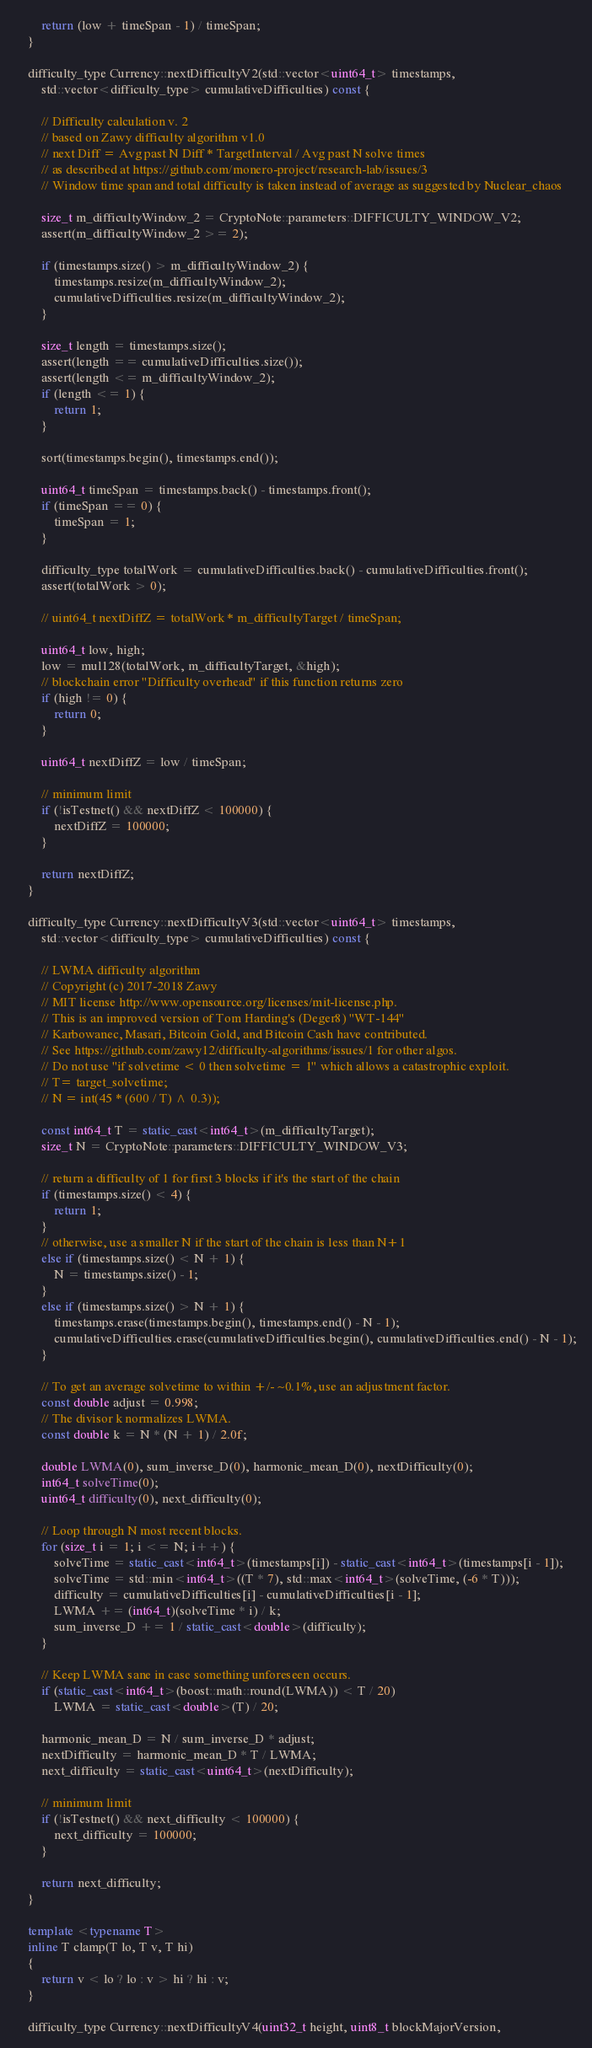<code> <loc_0><loc_0><loc_500><loc_500><_C++_>
		return (low + timeSpan - 1) / timeSpan;
	}

	difficulty_type Currency::nextDifficultyV2(std::vector<uint64_t> timestamps,
		std::vector<difficulty_type> cumulativeDifficulties) const {

		// Difficulty calculation v. 2
		// based on Zawy difficulty algorithm v1.0
		// next Diff = Avg past N Diff * TargetInterval / Avg past N solve times
		// as described at https://github.com/monero-project/research-lab/issues/3
		// Window time span and total difficulty is taken instead of average as suggested by Nuclear_chaos

		size_t m_difficultyWindow_2 = CryptoNote::parameters::DIFFICULTY_WINDOW_V2;
		assert(m_difficultyWindow_2 >= 2);

		if (timestamps.size() > m_difficultyWindow_2) {
			timestamps.resize(m_difficultyWindow_2);
			cumulativeDifficulties.resize(m_difficultyWindow_2);
		}

		size_t length = timestamps.size();
		assert(length == cumulativeDifficulties.size());
		assert(length <= m_difficultyWindow_2);
		if (length <= 1) {
			return 1;
		}

		sort(timestamps.begin(), timestamps.end());

		uint64_t timeSpan = timestamps.back() - timestamps.front();
		if (timeSpan == 0) {
			timeSpan = 1;
		}

		difficulty_type totalWork = cumulativeDifficulties.back() - cumulativeDifficulties.front();
		assert(totalWork > 0);

		// uint64_t nextDiffZ = totalWork * m_difficultyTarget / timeSpan; 

		uint64_t low, high;
		low = mul128(totalWork, m_difficultyTarget, &high);
		// blockchain error "Difficulty overhead" if this function returns zero
		if (high != 0) {
			return 0;
		}

		uint64_t nextDiffZ = low / timeSpan;

		// minimum limit
		if (!isTestnet() && nextDiffZ < 100000) {
			nextDiffZ = 100000;
		}

		return nextDiffZ;
	}

	difficulty_type Currency::nextDifficultyV3(std::vector<uint64_t> timestamps,
		std::vector<difficulty_type> cumulativeDifficulties) const {

		// LWMA difficulty algorithm
		// Copyright (c) 2017-2018 Zawy
		// MIT license http://www.opensource.org/licenses/mit-license.php.
		// This is an improved version of Tom Harding's (Deger8) "WT-144"  
		// Karbowanec, Masari, Bitcoin Gold, and Bitcoin Cash have contributed.
		// See https://github.com/zawy12/difficulty-algorithms/issues/1 for other algos.
		// Do not use "if solvetime < 0 then solvetime = 1" which allows a catastrophic exploit.
		// T= target_solvetime;
		// N = int(45 * (600 / T) ^ 0.3));

		const int64_t T = static_cast<int64_t>(m_difficultyTarget);
		size_t N = CryptoNote::parameters::DIFFICULTY_WINDOW_V3;

		// return a difficulty of 1 for first 3 blocks if it's the start of the chain
		if (timestamps.size() < 4) {
			return 1;
		}
		// otherwise, use a smaller N if the start of the chain is less than N+1
		else if (timestamps.size() < N + 1) {
			N = timestamps.size() - 1;
		}
		else if (timestamps.size() > N + 1) {
			timestamps.erase(timestamps.begin(), timestamps.end() - N - 1);
			cumulativeDifficulties.erase(cumulativeDifficulties.begin(), cumulativeDifficulties.end() - N - 1);
		}

		// To get an average solvetime to within +/- ~0.1%, use an adjustment factor.
		const double adjust = 0.998;
		// The divisor k normalizes LWMA.
		const double k = N * (N + 1) / 2.0f;

		double LWMA(0), sum_inverse_D(0), harmonic_mean_D(0), nextDifficulty(0);
		int64_t solveTime(0);
		uint64_t difficulty(0), next_difficulty(0);

		// Loop through N most recent blocks.
		for (size_t i = 1; i <= N; i++) {
			solveTime = static_cast<int64_t>(timestamps[i]) - static_cast<int64_t>(timestamps[i - 1]);
			solveTime = std::min<int64_t>((T * 7), std::max<int64_t>(solveTime, (-6 * T)));
			difficulty = cumulativeDifficulties[i] - cumulativeDifficulties[i - 1];
			LWMA += (int64_t)(solveTime * i) / k;
			sum_inverse_D += 1 / static_cast<double>(difficulty);
		}

		// Keep LWMA sane in case something unforeseen occurs.
		if (static_cast<int64_t>(boost::math::round(LWMA)) < T / 20)
			LWMA = static_cast<double>(T) / 20;

		harmonic_mean_D = N / sum_inverse_D * adjust;
		nextDifficulty = harmonic_mean_D * T / LWMA;
		next_difficulty = static_cast<uint64_t>(nextDifficulty);
		
		// minimum limit
		if (!isTestnet() && next_difficulty < 100000) {
			next_difficulty = 100000;
		}

		return next_difficulty;
	}

	template <typename T>
	inline T clamp(T lo, T v, T hi)
	{
		return v < lo ? lo : v > hi ? hi : v;
	}

	difficulty_type Currency::nextDifficultyV4(uint32_t height, uint8_t blockMajorVersion,</code> 